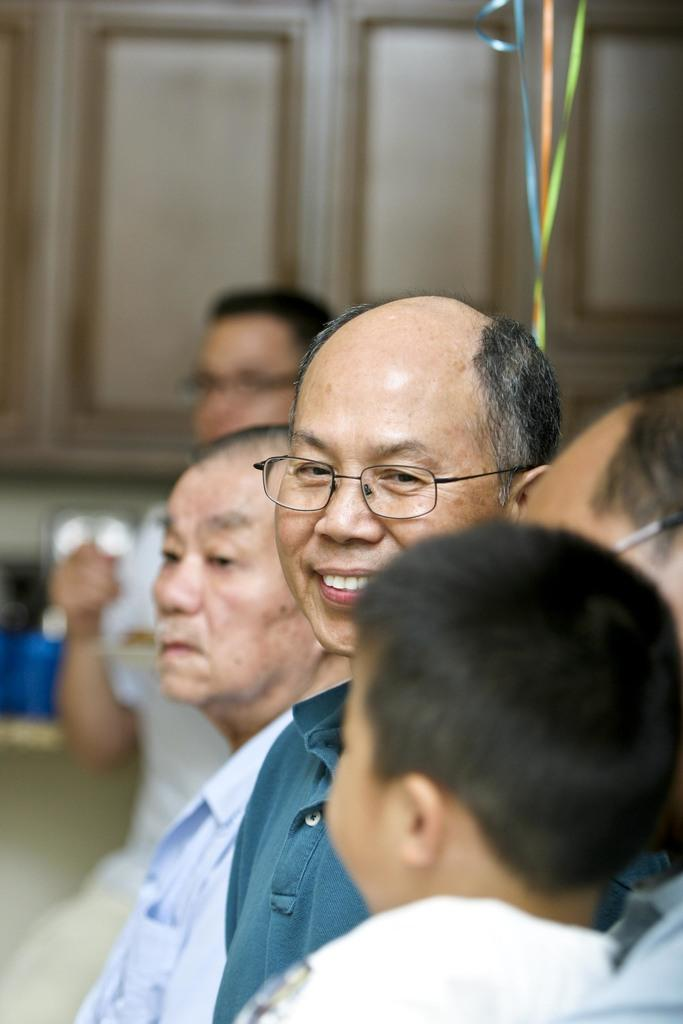What is the main subject in the foreground of the image? There is a group of people in the foreground of the image. What can be seen in the middle of the image? There are ribbons in the middle of the image. How would you describe the background of the image? The background of the image is blurred. Can you identify any other people in the image? Yes, there is a person visible in the background of the image. What type of objects can be seen in the background of the image? There are wooden objects in the background of the image. Where is the tiger located in the image? There is no tiger present in the image. What type of mass is being held by the group of people in the image? The image does not provide information about any mass or gathering being held by the group of people. 